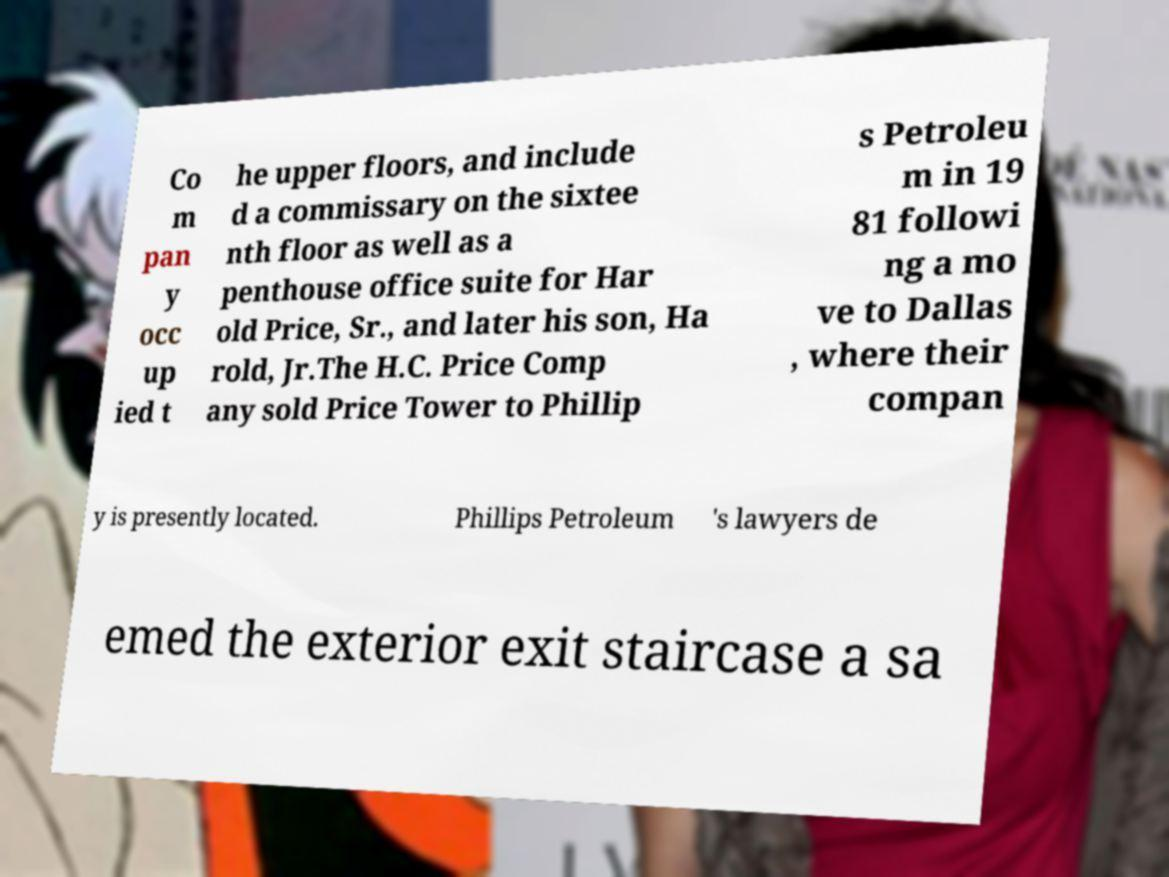Could you extract and type out the text from this image? Co m pan y occ up ied t he upper floors, and include d a commissary on the sixtee nth floor as well as a penthouse office suite for Har old Price, Sr., and later his son, Ha rold, Jr.The H.C. Price Comp any sold Price Tower to Phillip s Petroleu m in 19 81 followi ng a mo ve to Dallas , where their compan y is presently located. Phillips Petroleum 's lawyers de emed the exterior exit staircase a sa 